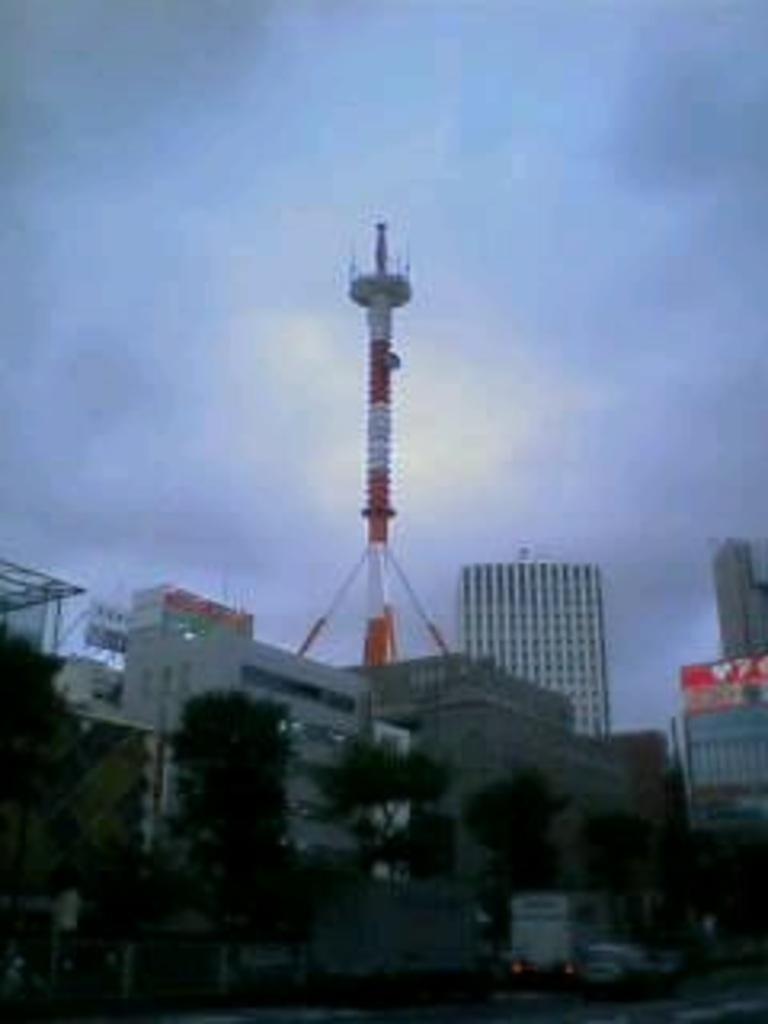Describe this image in one or two sentences. In this image I see number of buildings and trees and I see few vehicles over here and I see a tower over here. In the background I see the sky. 